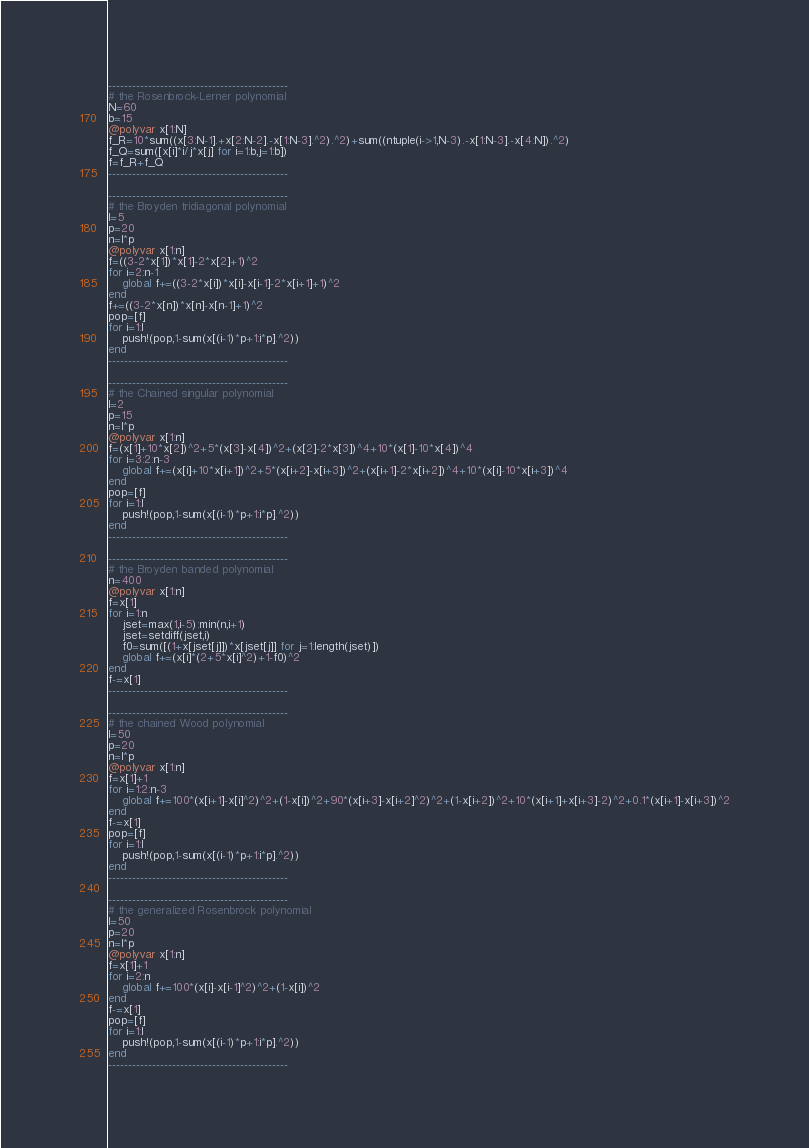<code> <loc_0><loc_0><loc_500><loc_500><_Julia_>---------------------------------------------
# the Rosenbrock-Lerner polynomial
N=60
b=15
@polyvar x[1:N]
f_R=10*sum((x[3:N-1].+x[2:N-2].-x[1:N-3].^2).^2)+sum((ntuple(i->1,N-3).-x[1:N-3].-x[4:N]).^2)
f_Q=sum([x[i]*i/j*x[j] for i=1:b,j=1:b])
f=f_R+f_Q
---------------------------------------------

---------------------------------------------
# the Broyden tridiagonal polynomial
l=5
p=20
n=l*p
@polyvar x[1:n]
f=((3-2*x[1])*x[1]-2*x[2]+1)^2
for i=2:n-1
    global f+=((3-2*x[i])*x[i]-x[i-1]-2*x[i+1]+1)^2
end
f+=((3-2*x[n])*x[n]-x[n-1]+1)^2
pop=[f]
for i=1:l
    push!(pop,1-sum(x[(i-1)*p+1:i*p].^2))
end
---------------------------------------------

---------------------------------------------
# the Chained singular polynomial
l=2
p=15
n=l*p
@polyvar x[1:n]
f=(x[1]+10*x[2])^2+5*(x[3]-x[4])^2+(x[2]-2*x[3])^4+10*(x[1]-10*x[4])^4
for i=3:2:n-3
    global f+=(x[i]+10*x[i+1])^2+5*(x[i+2]-x[i+3])^2+(x[i+1]-2*x[i+2])^4+10*(x[i]-10*x[i+3])^4
end
pop=[f]
for i=1:l
    push!(pop,1-sum(x[(i-1)*p+1:i*p].^2))
end
---------------------------------------------

---------------------------------------------
# the Broyden banded polynomial
n=400
@polyvar x[1:n]
f=x[1]
for i=1:n
    jset=max(1,i-5):min(n,i+1)
    jset=setdiff(jset,i)
    f0=sum([(1+x[jset[j]])*x[jset[j]] for j=1:length(jset)])
    global f+=(x[i]*(2+5*x[i]^2)+1-f0)^2
end
f-=x[1]
---------------------------------------------

---------------------------------------------
# the chained Wood polynomial
l=50
p=20
n=l*p
@polyvar x[1:n]
f=x[1]+1
for i=1:2:n-3
    global f+=100*(x[i+1]-x[i]^2)^2+(1-x[i])^2+90*(x[i+3]-x[i+2]^2)^2+(1-x[i+2])^2+10*(x[i+1]+x[i+3]-2)^2+0.1*(x[i+1]-x[i+3])^2
end
f-=x[1]
pop=[f]
for i=1:l
    push!(pop,1-sum(x[(i-1)*p+1:i*p].^2))
end
---------------------------------------------

---------------------------------------------
# the generalized Rosenbrock polynomial
l=50
p=20
n=l*p
@polyvar x[1:n]
f=x[1]+1
for i=2:n
    global f+=100*(x[i]-x[i-1]^2)^2+(1-x[i])^2
end
f-=x[1]
pop=[f]
for i=1:l
    push!(pop,1-sum(x[(i-1)*p+1:i*p].^2))
end
---------------------------------------------
</code> 